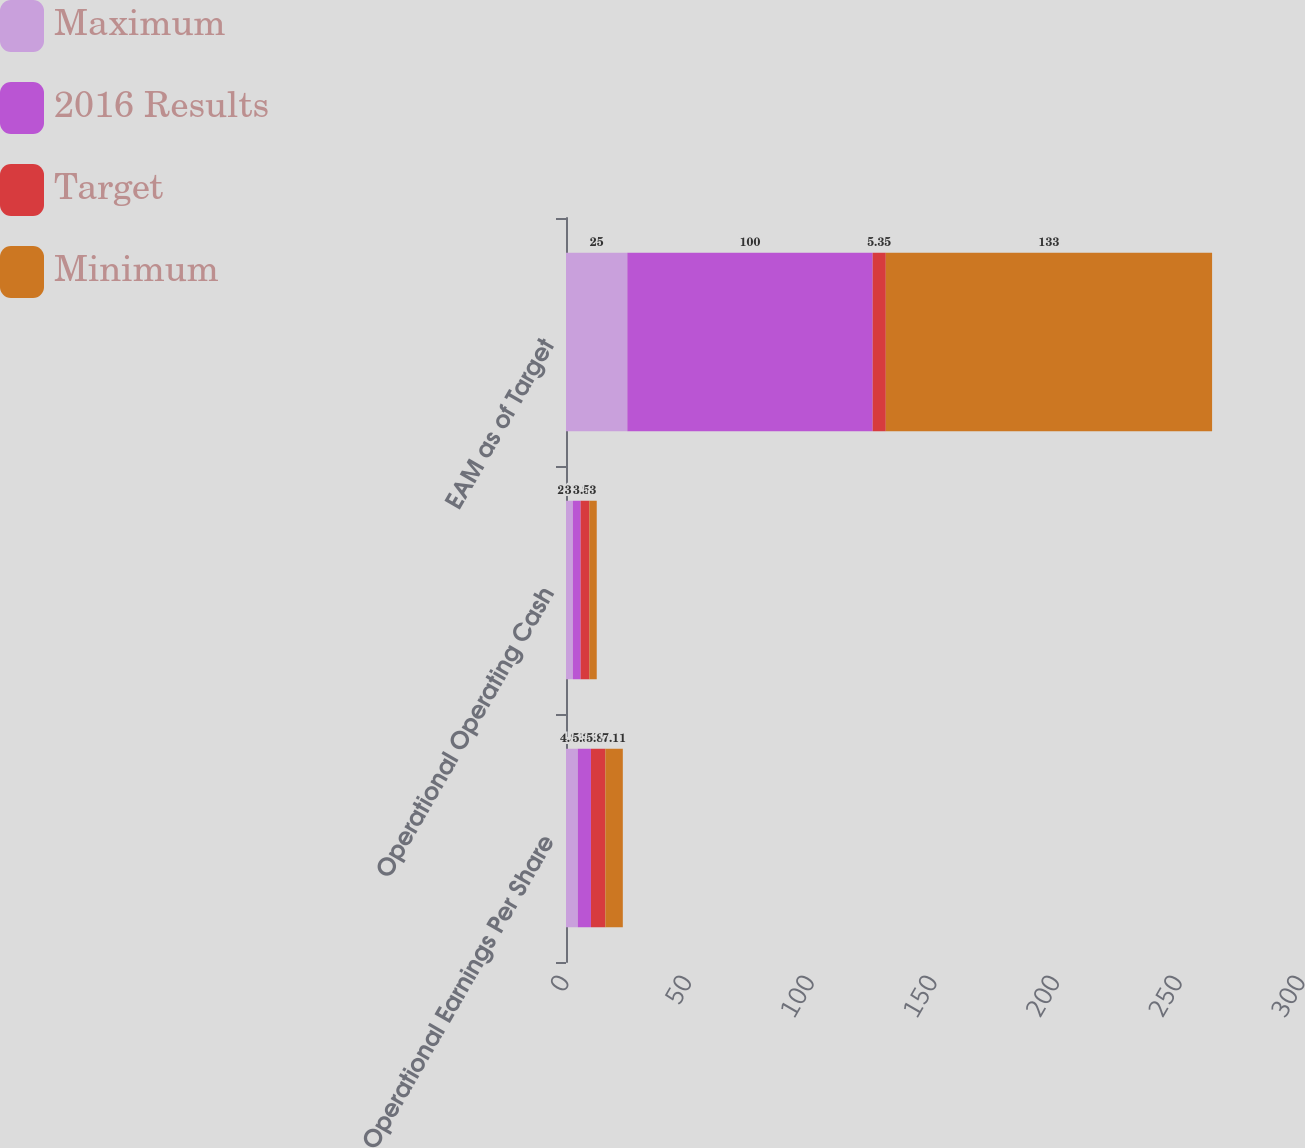Convert chart to OTSL. <chart><loc_0><loc_0><loc_500><loc_500><stacked_bar_chart><ecel><fcel>Operational Earnings Per Share<fcel>Operational Operating Cash<fcel>EAM as of Target<nl><fcel>Maximum<fcel>4.82<fcel>2.79<fcel>25<nl><fcel>2016 Results<fcel>5.35<fcel>3.18<fcel>100<nl><fcel>Target<fcel>5.88<fcel>3.56<fcel>5.35<nl><fcel>Minimum<fcel>7.11<fcel>3<fcel>133<nl></chart> 